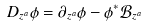<formula> <loc_0><loc_0><loc_500><loc_500>D _ { z ^ { a } } \phi = \partial _ { z ^ { a } } \phi - \phi ^ { * } \mathcal { B } _ { z ^ { a } }</formula> 